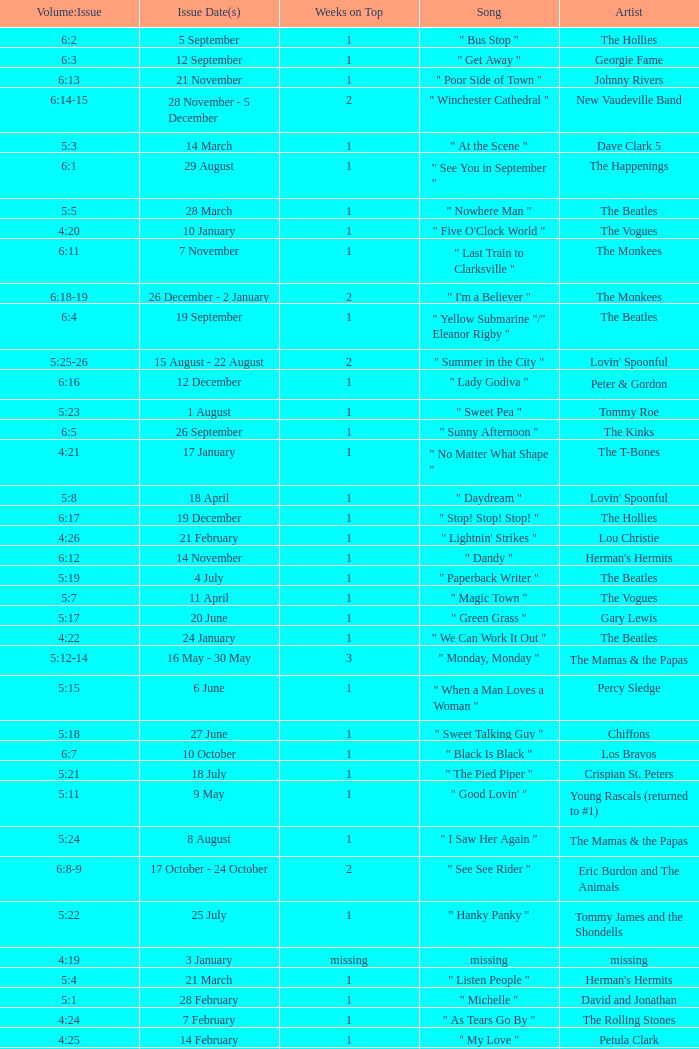With an issue date(s) of 12 September, what is in the column for Weeks on Top? 1.0. 